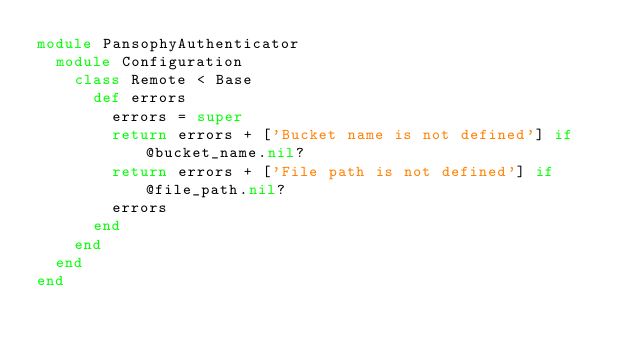Convert code to text. <code><loc_0><loc_0><loc_500><loc_500><_Ruby_>module PansophyAuthenticator
  module Configuration
    class Remote < Base
      def errors
        errors = super
        return errors + ['Bucket name is not defined'] if @bucket_name.nil?
        return errors + ['File path is not defined'] if @file_path.nil?
        errors
      end
    end
  end
end
</code> 